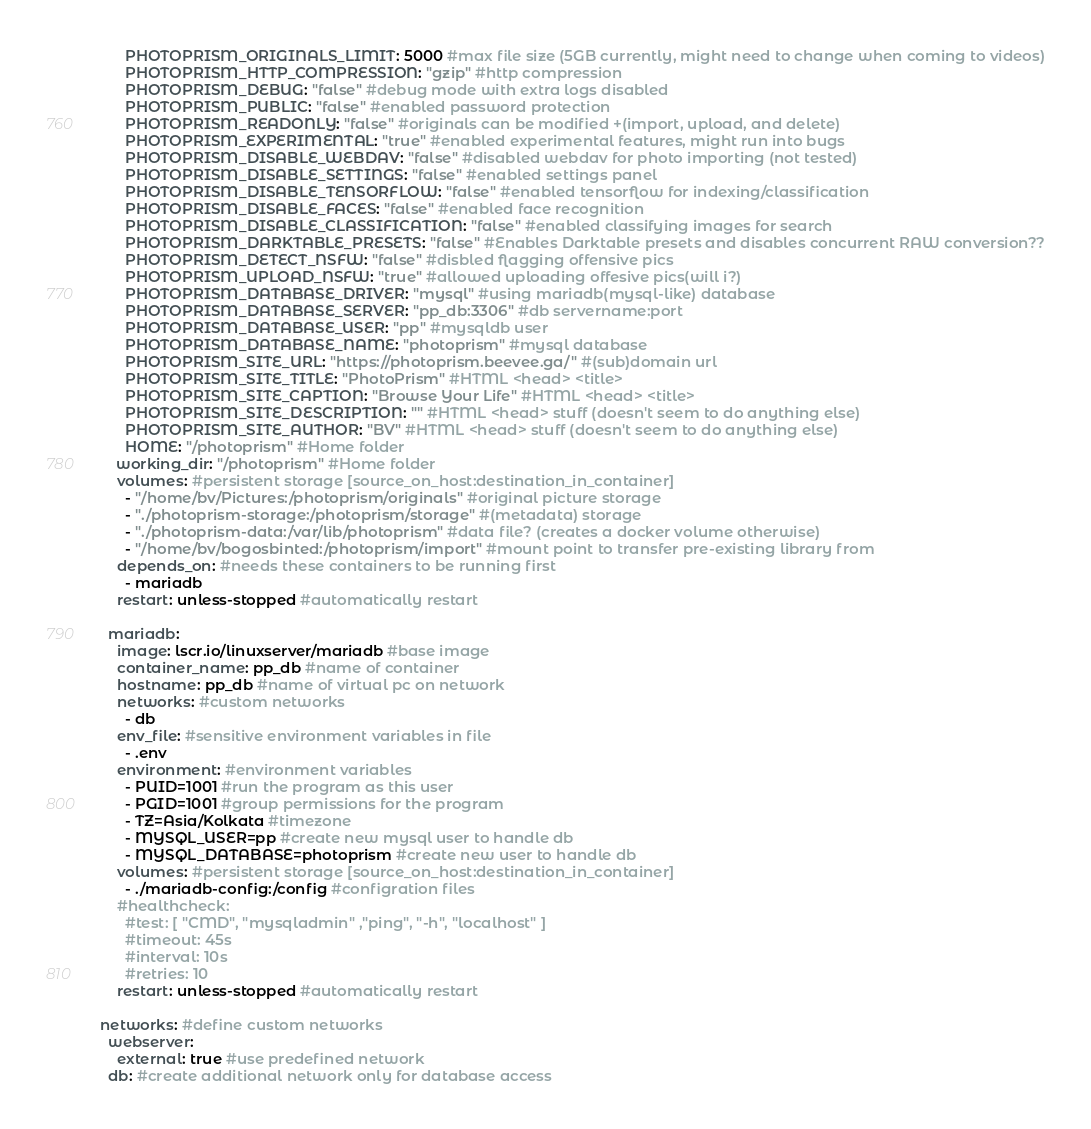<code> <loc_0><loc_0><loc_500><loc_500><_YAML_>      PHOTOPRISM_ORIGINALS_LIMIT: 5000 #max file size (5GB currently, might need to change when coming to videos)
      PHOTOPRISM_HTTP_COMPRESSION: "gzip" #http compression
      PHOTOPRISM_DEBUG: "false" #debug mode with extra logs disabled
      PHOTOPRISM_PUBLIC: "false" #enabled password protection
      PHOTOPRISM_READONLY: "false" #originals can be modified +(import, upload, and delete)
      PHOTOPRISM_EXPERIMENTAL: "true" #enabled experimental features, might run into bugs
      PHOTOPRISM_DISABLE_WEBDAV: "false" #disabled webdav for photo importing (not tested)
      PHOTOPRISM_DISABLE_SETTINGS: "false" #enabled settings panel
      PHOTOPRISM_DISABLE_TENSORFLOW: "false" #enabled tensorflow for indexing/classification
      PHOTOPRISM_DISABLE_FACES: "false" #enabled face recognition
      PHOTOPRISM_DISABLE_CLASSIFICATION: "false" #enabled classifying images for search
      PHOTOPRISM_DARKTABLE_PRESETS: "false" #Enables Darktable presets and disables concurrent RAW conversion??
      PHOTOPRISM_DETECT_NSFW: "false" #disbled flagging offensive pics
      PHOTOPRISM_UPLOAD_NSFW: "true" #allowed uploading offesive pics(will i?)
      PHOTOPRISM_DATABASE_DRIVER: "mysql" #using mariadb(mysql-like) database
      PHOTOPRISM_DATABASE_SERVER: "pp_db:3306" #db servername:port
      PHOTOPRISM_DATABASE_USER: "pp" #mysqldb user
      PHOTOPRISM_DATABASE_NAME: "photoprism" #mysql database
      PHOTOPRISM_SITE_URL: "https://photoprism.beevee.ga/" #(sub)domain url
      PHOTOPRISM_SITE_TITLE: "PhotoPrism" #HTML <head> <title>
      PHOTOPRISM_SITE_CAPTION: "Browse Your Life" #HTML <head> <title>
      PHOTOPRISM_SITE_DESCRIPTION: "" #HTML <head> stuff (doesn't seem to do anything else)
      PHOTOPRISM_SITE_AUTHOR: "BV" #HTML <head> stuff (doesn't seem to do anything else)
      HOME: "/photoprism" #Home folder
    working_dir: "/photoprism" #Home folder 
    volumes: #persistent storage [source_on_host:destination_in_container]
      - "/home/bv/Pictures:/photoprism/originals" #original picture storage
      - "./photoprism-storage:/photoprism/storage" #(metadata) storage
      - "./photoprism-data:/var/lib/photoprism" #data file? (creates a docker volume otherwise)
      - "/home/bv/bogosbinted:/photoprism/import" #mount point to transfer pre-existing library from
    depends_on: #needs these containers to be running first
      - mariadb
    restart: unless-stopped #automatically restart 

  mariadb:
    image: lscr.io/linuxserver/mariadb #base image
    container_name: pp_db #name of container
    hostname: pp_db #name of virtual pc on network
    networks: #custom networks
      - db
    env_file: #sensitive environment variables in file 
      - .env
    environment: #environment variables
      - PUID=1001 #run the program as this user
      - PGID=1001 #group permissions for the program
      - TZ=Asia/Kolkata #timezone
      - MYSQL_USER=pp #create new mysql user to handle db
      - MYSQL_DATABASE=photoprism #create new user to handle db
    volumes: #persistent storage [source_on_host:destination_in_container]
      - ./mariadb-config:/config #configration files
    #healthcheck:
      #test: [ "CMD", "mysqladmin" ,"ping", "-h", "localhost" ]
      #timeout: 45s
      #interval: 10s
      #retries: 10
    restart: unless-stopped #automatically restart 

networks: #define custom networks
  webserver:
    external: true #use predefined network
  db: #create additional network only for database access
</code> 